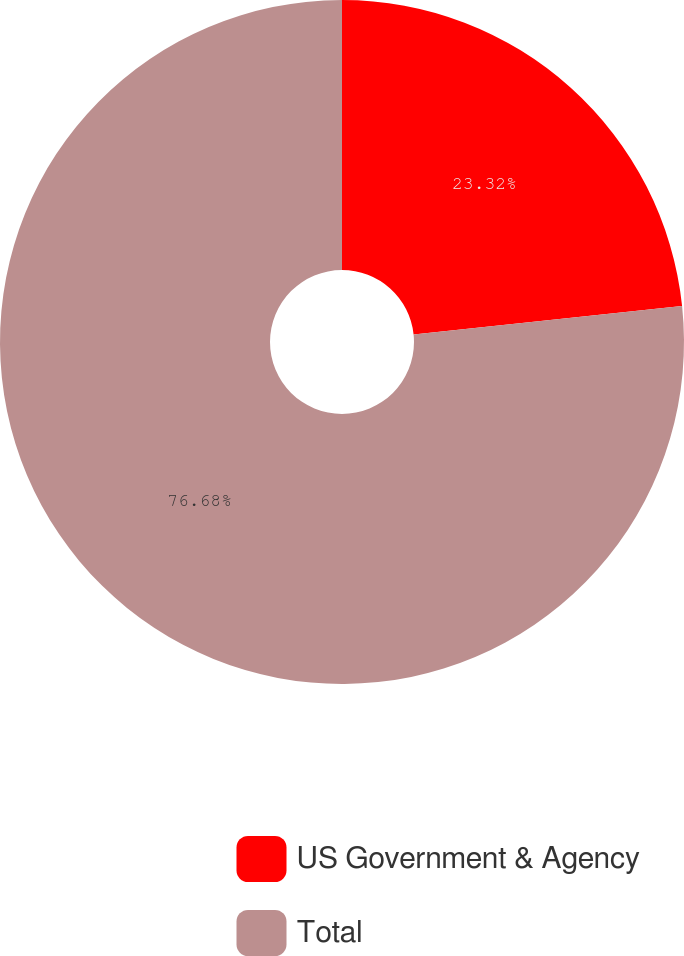Convert chart. <chart><loc_0><loc_0><loc_500><loc_500><pie_chart><fcel>US Government & Agency<fcel>Total<nl><fcel>23.32%<fcel>76.68%<nl></chart> 